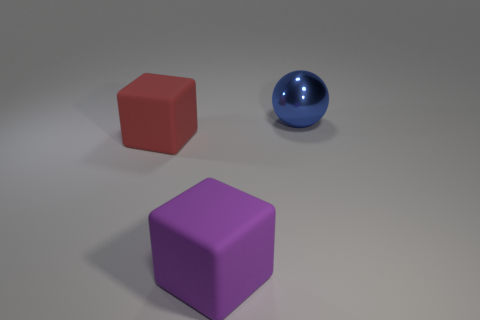Add 2 blue metal spheres. How many objects exist? 5 Subtract all balls. How many objects are left? 2 Add 1 large rubber objects. How many large rubber objects are left? 3 Add 3 big spheres. How many big spheres exist? 4 Subtract 1 purple cubes. How many objects are left? 2 Subtract all red matte objects. Subtract all tiny brown matte cylinders. How many objects are left? 2 